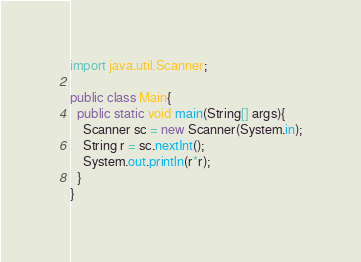<code> <loc_0><loc_0><loc_500><loc_500><_Java_>import java.util.Scanner;
 
public class Main{
  public static void main(String[] args){
    Scanner sc = new Scanner(System.in);
    String r = sc.nextInt();   
    System.out.println(r*r);
  }
}</code> 